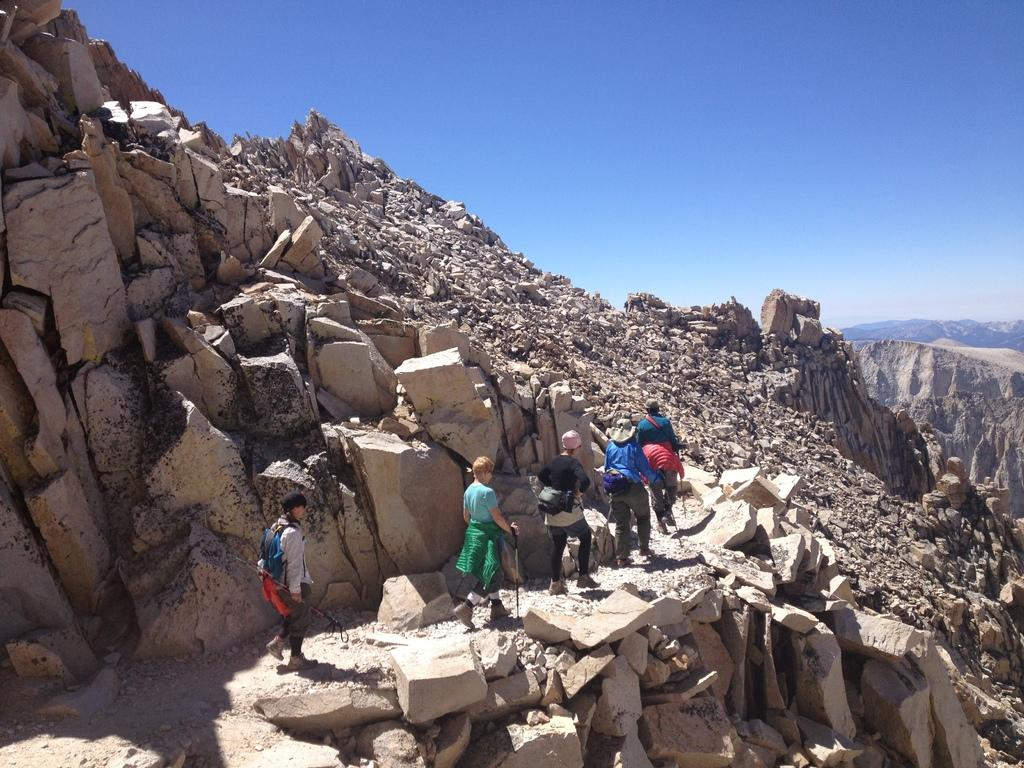What type of natural formation can be seen in the image? The image contains mountains. What are the people in the image doing? The people in the image are walking. What color is the sky in the image? The sky is blue in color. What type of ground surface can be seen in the image? There are stones visible in the image. Can you see a pet pig walking alongside the people in the image? There is no pig, pet or otherwise, visible in the image. 